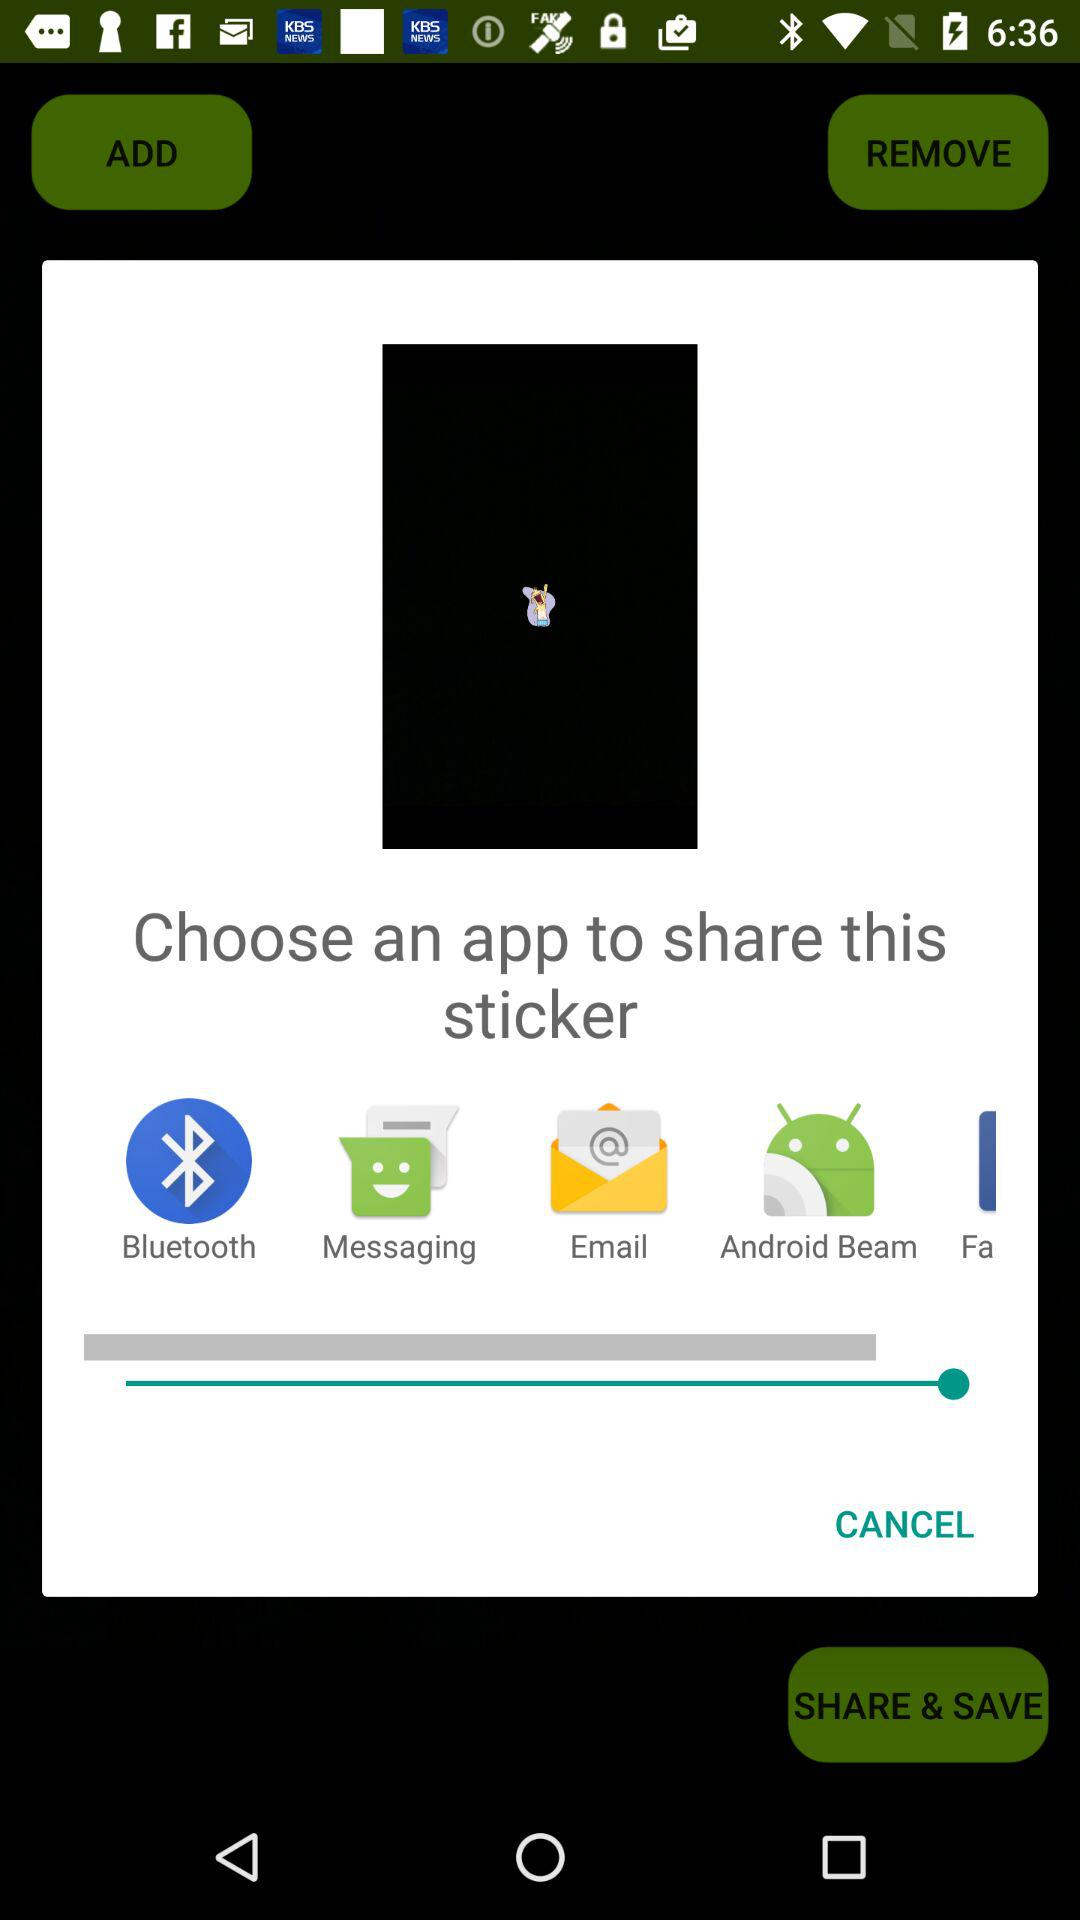Through which application can we share this sticker? You can share this sticker through "Bluetooth", "Messaging", "Email" and "Android Beam". 